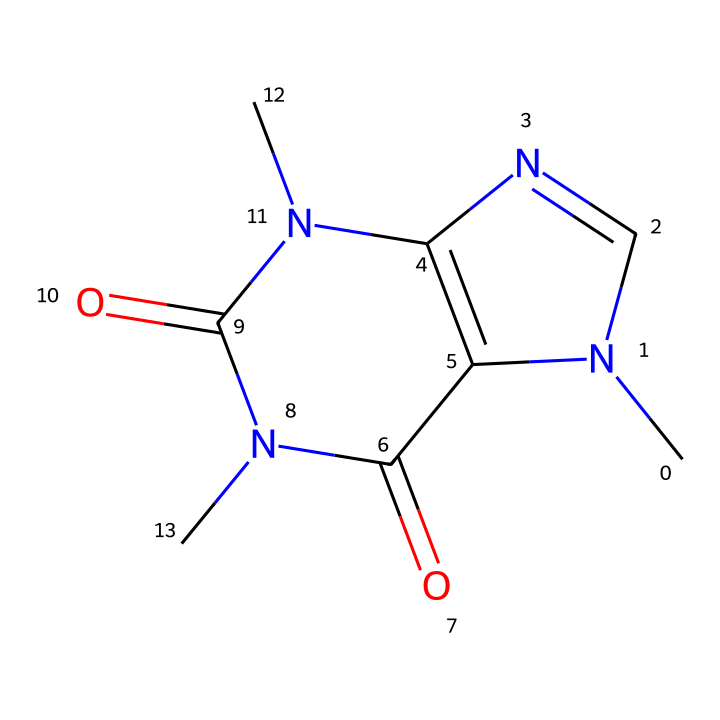How many nitrogen atoms are present in this compound? By analyzing the SMILES representation, we can see the presence of multiple 'N' symbols, which denote nitrogen atoms. Counting them yields a total of three nitrogen atoms in the structure.
Answer: three What is the total number of carbon atoms in the compound? By examining the SMILES notation, the number of 'C' symbols indicates the presence of carbon atoms. Counting all instances of 'C', we find that there are eight carbon atoms in the molecular structure.
Answer: eight What type of compound is caffeine categorized as? The presence of nitrogen atoms and the specific functionality of the structure, including both aromatic and aliphatic elements, leads us to categorize caffeine as an alkaloid, which is a group known for containing basic nitrogen atoms and having biological effects.
Answer: alkaloid What is the molecular formula for caffeine based on the SMILES? To derive the molecular formula from the SMILES representation, we count the atoms identified: 8 carbons (C), 10 hydrogens (H), 4 nitrogens (N), and 2 oxygens (O). Thus, the molecular formula is C8H10N4O2.
Answer: C8H10N4O2 Which functional groups are present in caffeine? In examining the structure represented in the SMILES, functional groups can be identified by their specific patterns: we can denote amide groups based on the presence of 'C(=O)N'. There are multiple amide functionalities evident in caffeine’s structure.
Answer: amide What is the general impact of caffeine as an alkaloid on human physiology? The classification as an alkaloid, combined with its function as a stimulant, suggests that caffeine acts on the central nervous system, enhancing alertness and potentially improving physical performance during activities. This is particularly relevant for athletes.
Answer: stimulant 